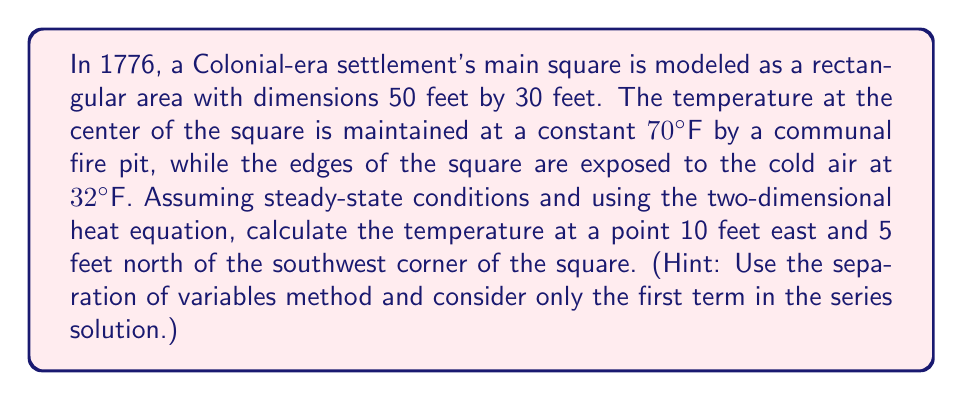Give your solution to this math problem. Let's approach this step-by-step using the two-dimensional steady-state heat equation:

1) The steady-state heat equation in 2D is:

   $$\frac{\partial^2 T}{\partial x^2} + \frac{\partial^2 T}{\partial y^2} = 0$$

2) We have the following boundary conditions:
   T(0,y) = T(50,y) = T(x,0) = T(x,30) = 32°F
   T(25,15) = 70°F (center)

3) Using separation of variables, we can write the solution as:

   $$T(x,y) = 32 + \sum_{m=1}^{\infty}\sum_{n=1}^{\infty} A_{mn}\sin(\frac{m\pi x}{50})\sin(\frac{n\pi y}{30})$$

4) Considering only the first term (m=1, n=1):

   $$T(x,y) \approx 32 + A_{11}\sin(\frac{\pi x}{50})\sin(\frac{\pi y}{30})$$

5) To find A₁₁, we use the condition at the center:

   $$70 = 32 + A_{11}\sin(\frac{\pi}{2})\sin(\frac{\pi}{2})$$
   $$A_{11} = 38$$

6) So our approximate solution is:

   $$T(x,y) \approx 32 + 38\sin(\frac{\pi x}{50})\sin(\frac{\pi y}{30})$$

7) For the point (10,5):

   $$T(10,5) \approx 32 + 38\sin(\frac{\pi \cdot 10}{50})\sin(\frac{\pi \cdot 5}{30})$$
   $$\approx 32 + 38 \cdot 0.5878 \cdot 0.5$$
   $$\approx 32 + 11.17$$
   $$\approx 43.17°F$$
Answer: 43.17°F 